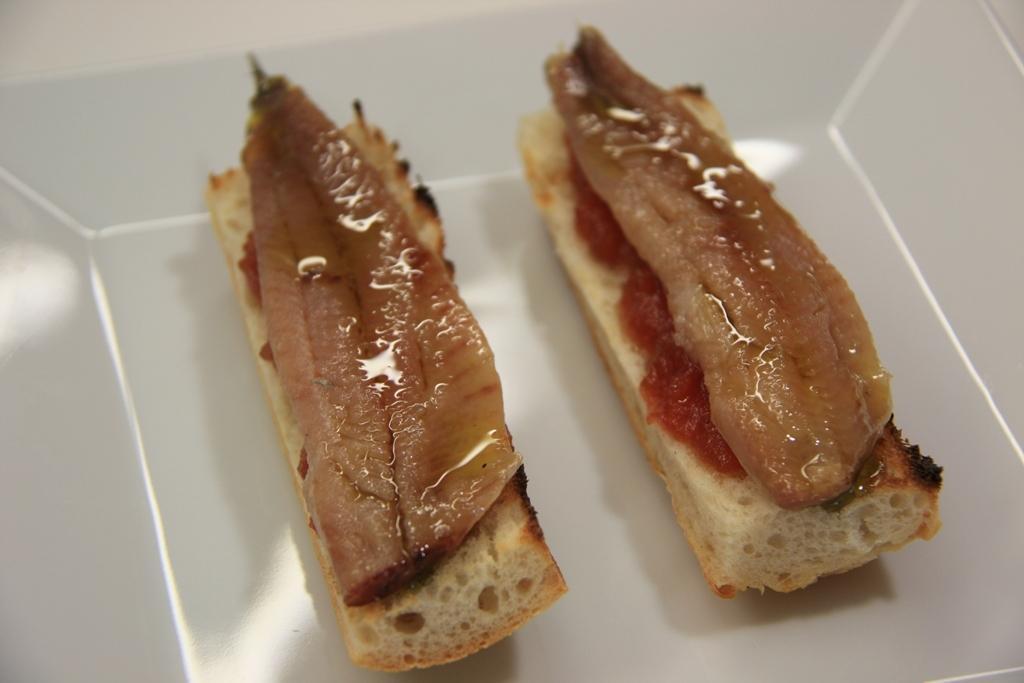Can you describe this image briefly? In this picture we can see some food item in a white object. 